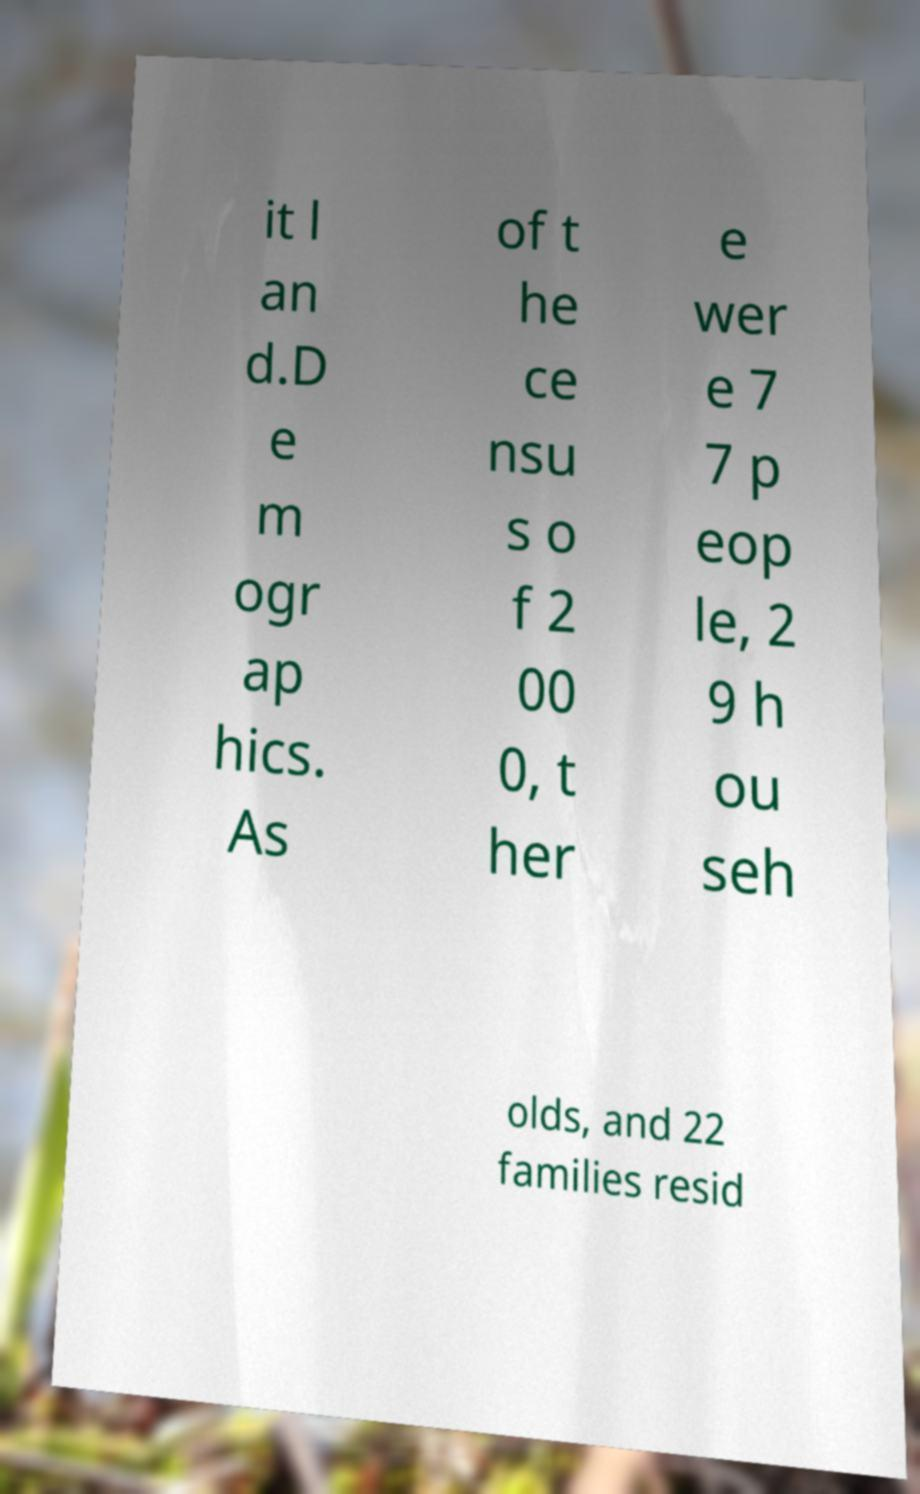Please identify and transcribe the text found in this image. it l an d.D e m ogr ap hics. As of t he ce nsu s o f 2 00 0, t her e wer e 7 7 p eop le, 2 9 h ou seh olds, and 22 families resid 